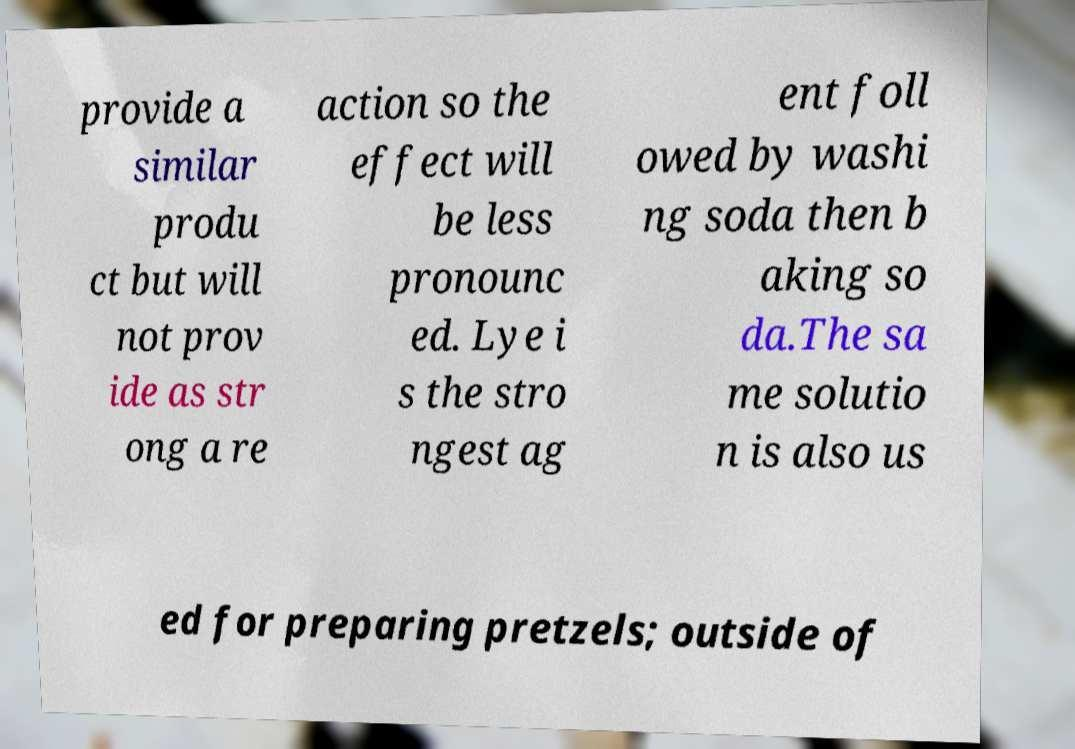Could you extract and type out the text from this image? provide a similar produ ct but will not prov ide as str ong a re action so the effect will be less pronounc ed. Lye i s the stro ngest ag ent foll owed by washi ng soda then b aking so da.The sa me solutio n is also us ed for preparing pretzels; outside of 